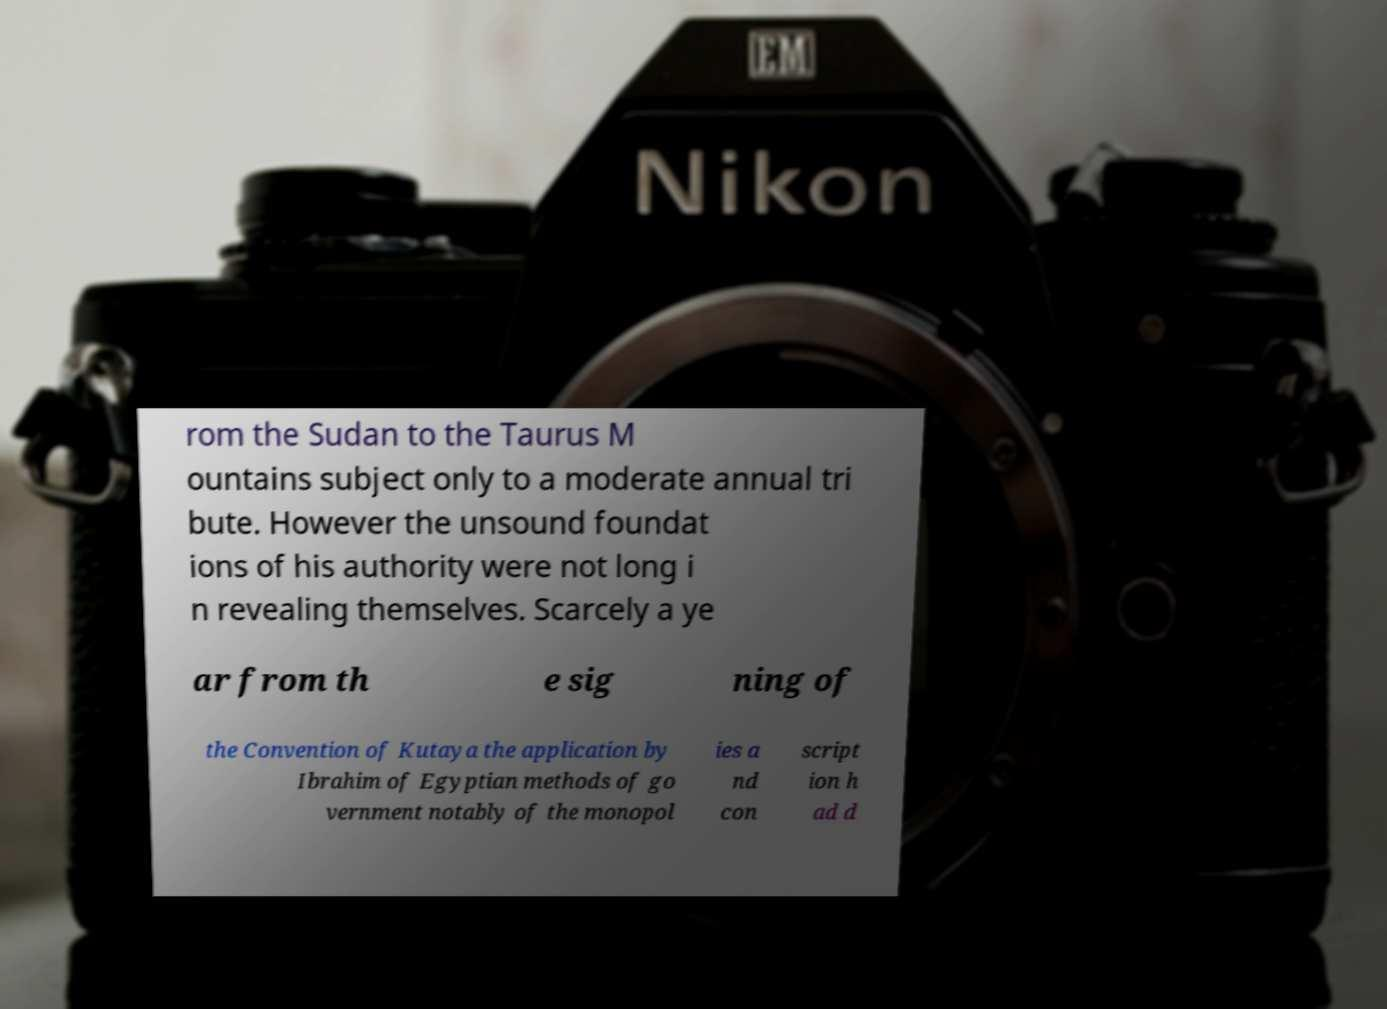I need the written content from this picture converted into text. Can you do that? rom the Sudan to the Taurus M ountains subject only to a moderate annual tri bute. However the unsound foundat ions of his authority were not long i n revealing themselves. Scarcely a ye ar from th e sig ning of the Convention of Kutaya the application by Ibrahim of Egyptian methods of go vernment notably of the monopol ies a nd con script ion h ad d 